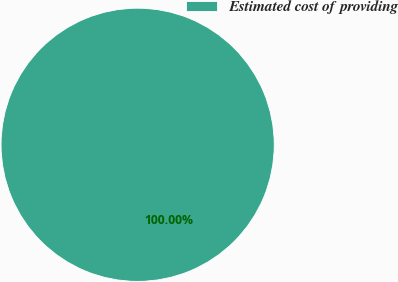Convert chart. <chart><loc_0><loc_0><loc_500><loc_500><pie_chart><fcel>Estimated cost of providing<nl><fcel>100.0%<nl></chart> 